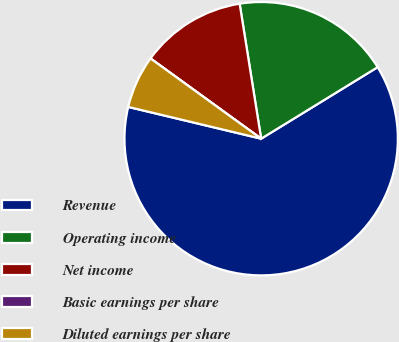Convert chart. <chart><loc_0><loc_0><loc_500><loc_500><pie_chart><fcel>Revenue<fcel>Operating income<fcel>Net income<fcel>Basic earnings per share<fcel>Diluted earnings per share<nl><fcel>62.5%<fcel>18.75%<fcel>12.5%<fcel>0.0%<fcel>6.25%<nl></chart> 